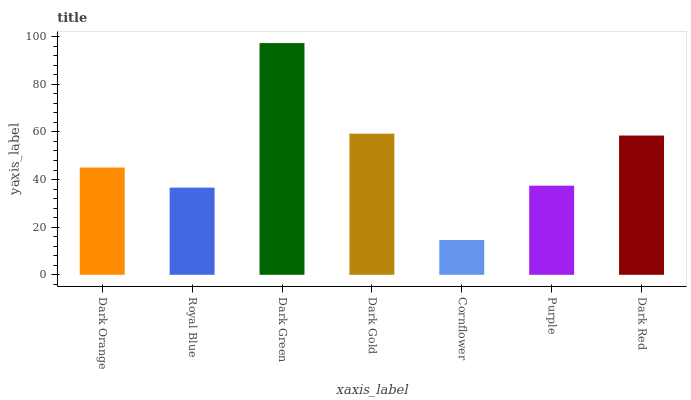Is Cornflower the minimum?
Answer yes or no. Yes. Is Dark Green the maximum?
Answer yes or no. Yes. Is Royal Blue the minimum?
Answer yes or no. No. Is Royal Blue the maximum?
Answer yes or no. No. Is Dark Orange greater than Royal Blue?
Answer yes or no. Yes. Is Royal Blue less than Dark Orange?
Answer yes or no. Yes. Is Royal Blue greater than Dark Orange?
Answer yes or no. No. Is Dark Orange less than Royal Blue?
Answer yes or no. No. Is Dark Orange the high median?
Answer yes or no. Yes. Is Dark Orange the low median?
Answer yes or no. Yes. Is Royal Blue the high median?
Answer yes or no. No. Is Dark Green the low median?
Answer yes or no. No. 